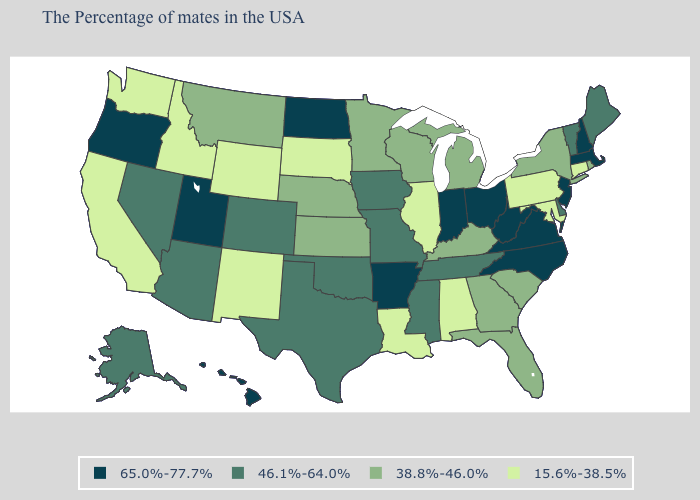Does Wisconsin have the highest value in the MidWest?
Keep it brief. No. Which states have the highest value in the USA?
Answer briefly. Massachusetts, New Hampshire, New Jersey, Virginia, North Carolina, West Virginia, Ohio, Indiana, Arkansas, North Dakota, Utah, Oregon, Hawaii. Among the states that border Idaho , does Utah have the highest value?
Concise answer only. Yes. Among the states that border North Carolina , does Georgia have the highest value?
Short answer required. No. What is the lowest value in states that border South Dakota?
Keep it brief. 15.6%-38.5%. Name the states that have a value in the range 65.0%-77.7%?
Concise answer only. Massachusetts, New Hampshire, New Jersey, Virginia, North Carolina, West Virginia, Ohio, Indiana, Arkansas, North Dakota, Utah, Oregon, Hawaii. How many symbols are there in the legend?
Give a very brief answer. 4. Which states have the highest value in the USA?
Give a very brief answer. Massachusetts, New Hampshire, New Jersey, Virginia, North Carolina, West Virginia, Ohio, Indiana, Arkansas, North Dakota, Utah, Oregon, Hawaii. Which states have the highest value in the USA?
Answer briefly. Massachusetts, New Hampshire, New Jersey, Virginia, North Carolina, West Virginia, Ohio, Indiana, Arkansas, North Dakota, Utah, Oregon, Hawaii. Does Arizona have the lowest value in the USA?
Be succinct. No. Does Florida have the same value as Connecticut?
Write a very short answer. No. Does Kansas have the same value as Alaska?
Concise answer only. No. What is the lowest value in states that border North Carolina?
Give a very brief answer. 38.8%-46.0%. Does the first symbol in the legend represent the smallest category?
Be succinct. No. What is the value of Nebraska?
Write a very short answer. 38.8%-46.0%. 